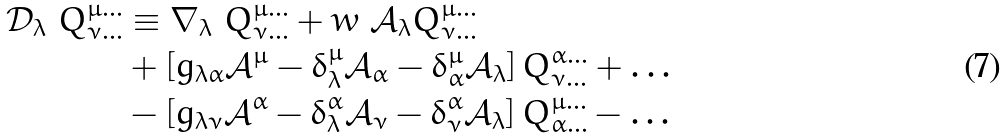Convert formula to latex. <formula><loc_0><loc_0><loc_500><loc_500>\mathcal { D } _ { \lambda } \ Q ^ { \mu \dots } _ { \nu \dots } & \equiv \nabla _ { \lambda } \ Q ^ { \mu \dots } _ { \nu \dots } + w \ \mathcal { A } _ { \lambda } Q ^ { \mu \dots } _ { \nu \dots } \\ & + \left [ { g } _ { \lambda \alpha } \mathcal { A } ^ { \mu } - \delta ^ { \mu } _ { \lambda } \mathcal { A } _ { \alpha } - \delta ^ { \mu } _ { \alpha } \mathcal { A } _ { \lambda } \right ] Q ^ { \alpha \dots } _ { \nu \dots } + \dots \\ & - \left [ { g } _ { \lambda \nu } \mathcal { A } ^ { \alpha } - \delta ^ { \alpha } _ { \lambda } \mathcal { A } _ { \nu } - \delta ^ { \alpha } _ { \nu } \mathcal { A } _ { \lambda } \right ] Q ^ { \mu \dots } _ { \alpha \dots } - \dots</formula> 